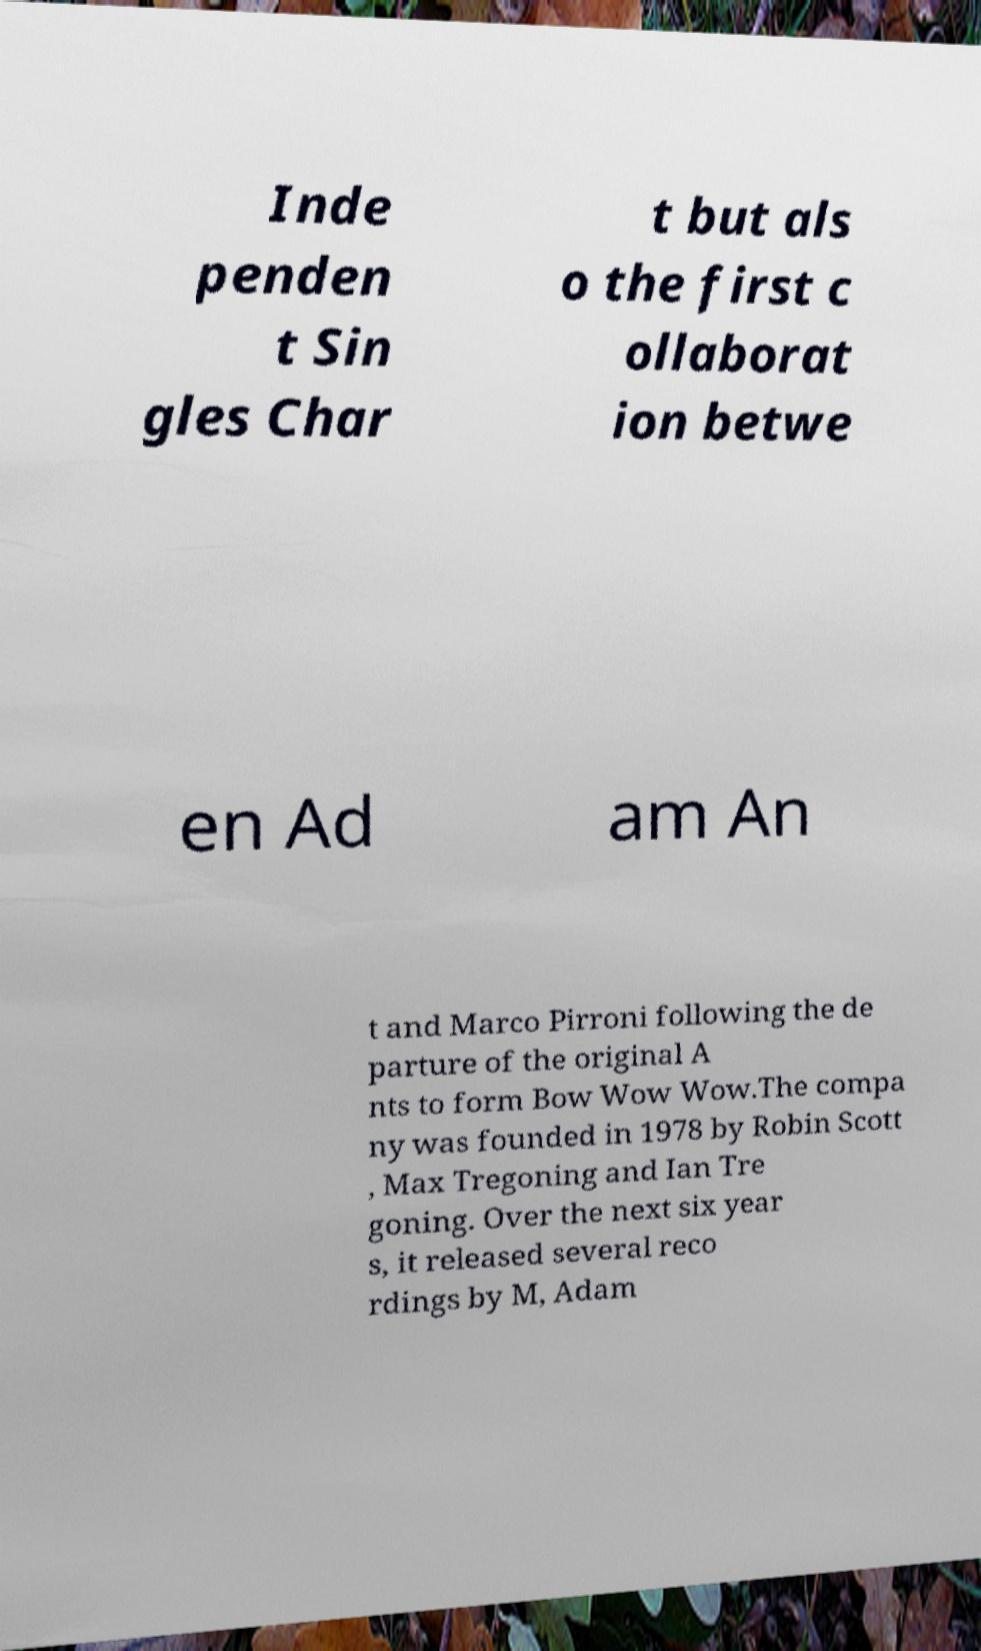Can you accurately transcribe the text from the provided image for me? Inde penden t Sin gles Char t but als o the first c ollaborat ion betwe en Ad am An t and Marco Pirroni following the de parture of the original A nts to form Bow Wow Wow.The compa ny was founded in 1978 by Robin Scott , Max Tregoning and Ian Tre goning. Over the next six year s, it released several reco rdings by M, Adam 